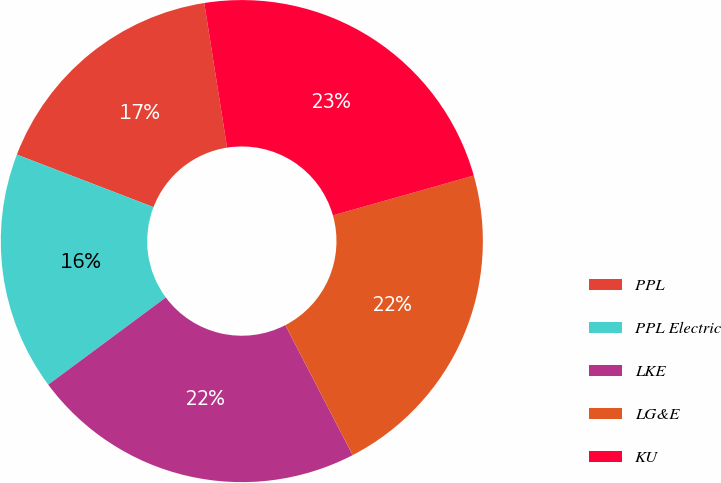<chart> <loc_0><loc_0><loc_500><loc_500><pie_chart><fcel>PPL<fcel>PPL Electric<fcel>LKE<fcel>LG&E<fcel>KU<nl><fcel>16.67%<fcel>16.0%<fcel>22.45%<fcel>21.78%<fcel>23.11%<nl></chart> 